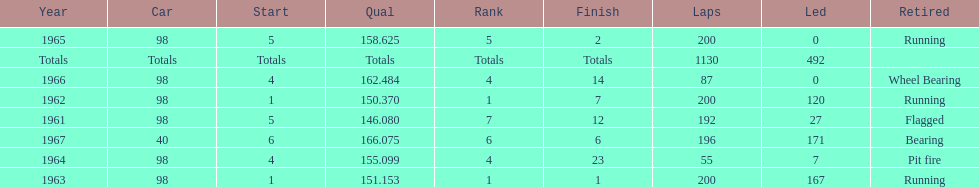In how many indy 500 races, has jones been flagged? 1. 